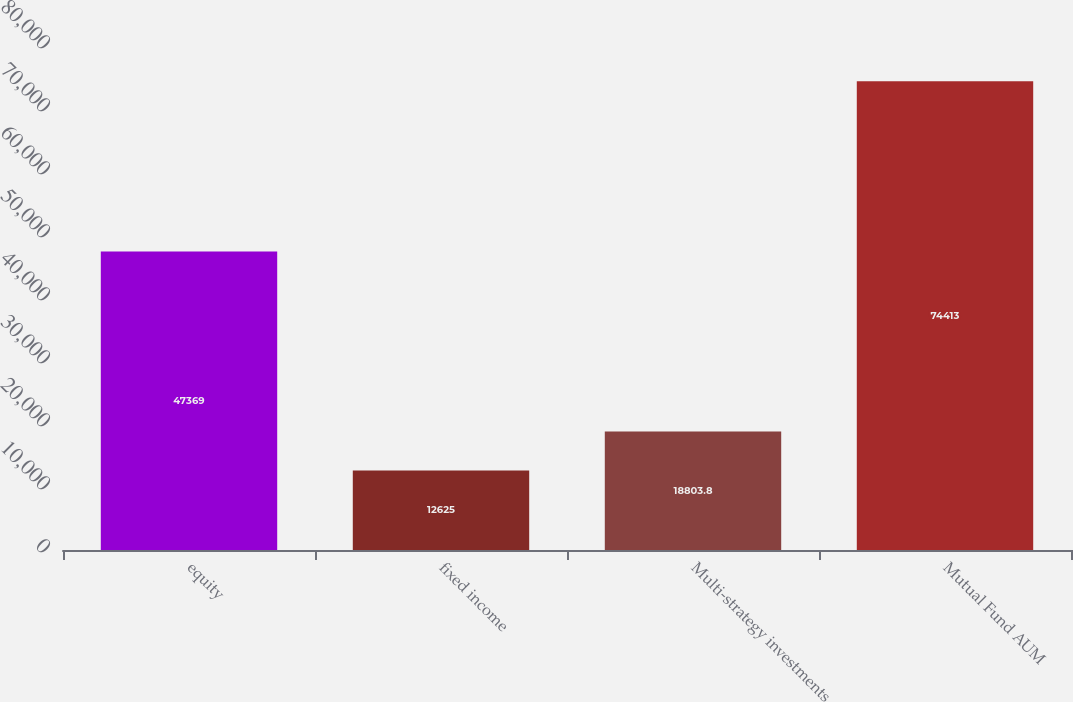Convert chart. <chart><loc_0><loc_0><loc_500><loc_500><bar_chart><fcel>equity<fcel>fixed income<fcel>Multi-strategy investments<fcel>Mutual Fund AUM<nl><fcel>47369<fcel>12625<fcel>18803.8<fcel>74413<nl></chart> 